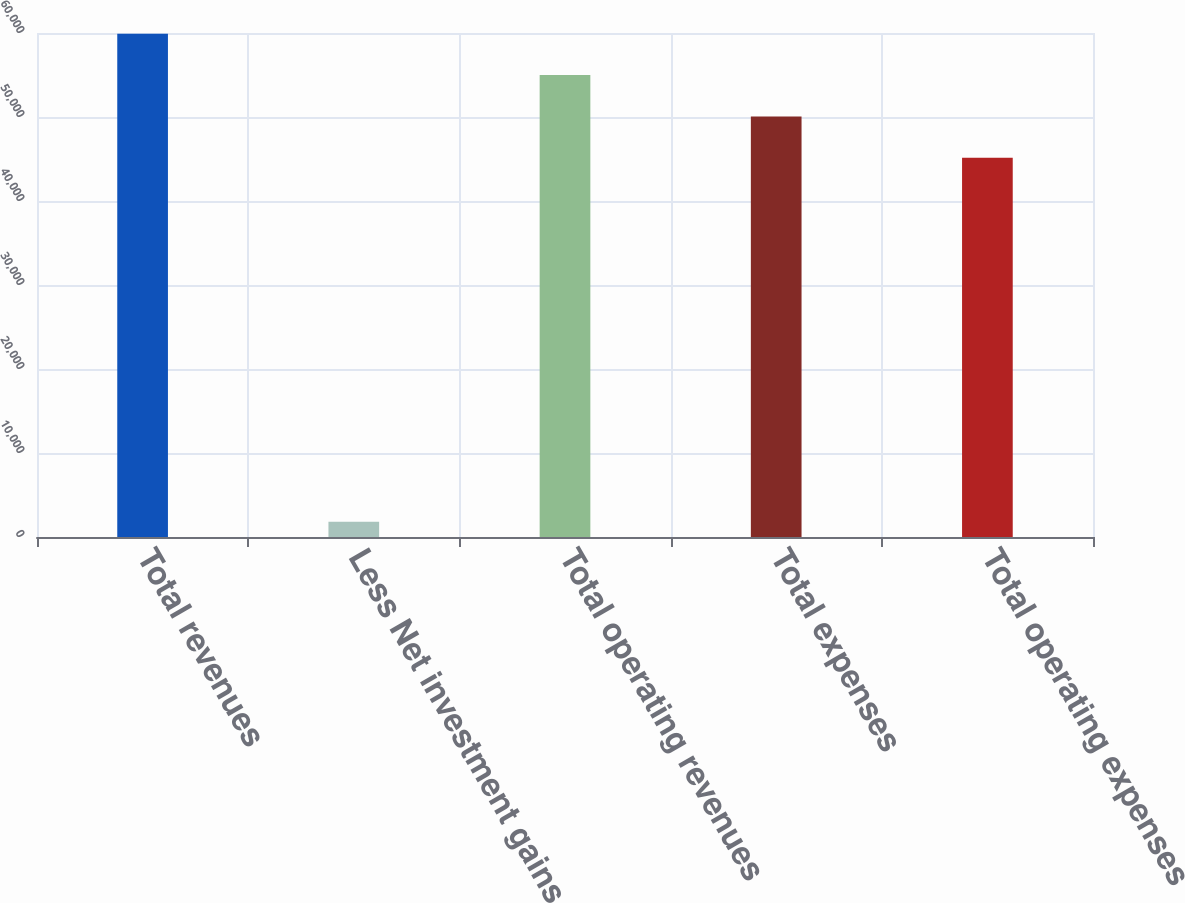Convert chart. <chart><loc_0><loc_0><loc_500><loc_500><bar_chart><fcel>Total revenues<fcel>Less Net investment gains<fcel>Total operating revenues<fcel>Total expenses<fcel>Total operating expenses<nl><fcel>59903.6<fcel>1812<fcel>54986.4<fcel>50069.2<fcel>45152<nl></chart> 